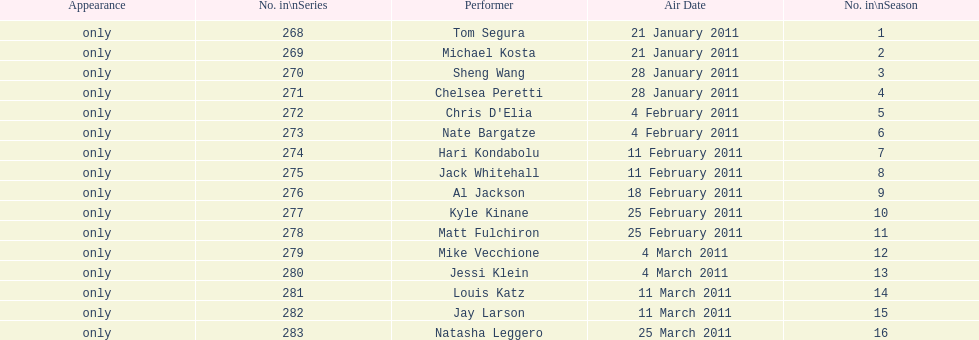How many different performers appeared during this season? 16. 